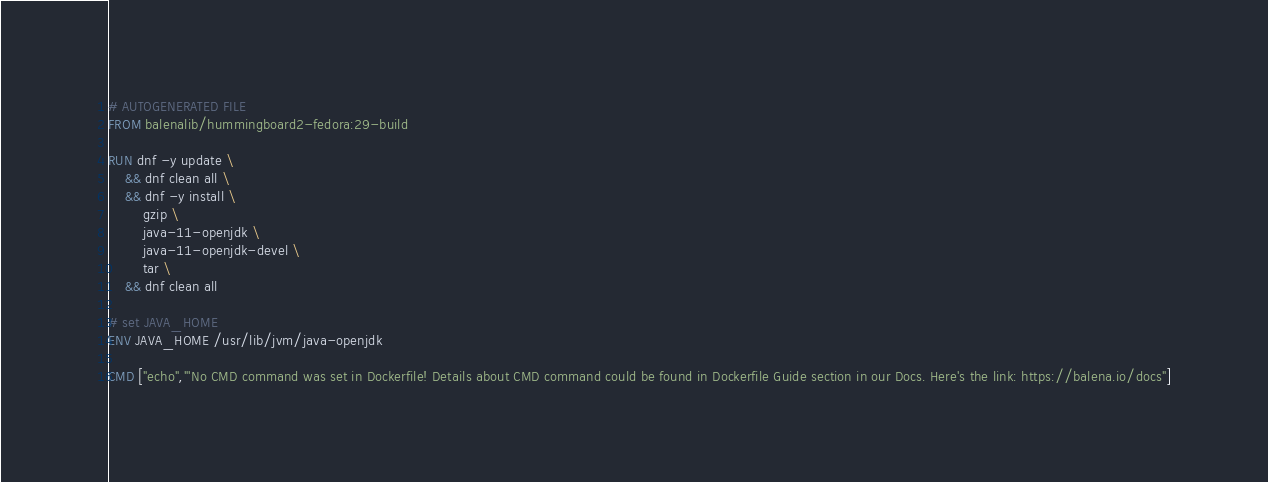<code> <loc_0><loc_0><loc_500><loc_500><_Dockerfile_># AUTOGENERATED FILE
FROM balenalib/hummingboard2-fedora:29-build

RUN dnf -y update \
	&& dnf clean all \
	&& dnf -y install \
		gzip \
		java-11-openjdk \
		java-11-openjdk-devel \
		tar \
	&& dnf clean all

# set JAVA_HOME
ENV JAVA_HOME /usr/lib/jvm/java-openjdk

CMD ["echo","'No CMD command was set in Dockerfile! Details about CMD command could be found in Dockerfile Guide section in our Docs. Here's the link: https://balena.io/docs"]
</code> 